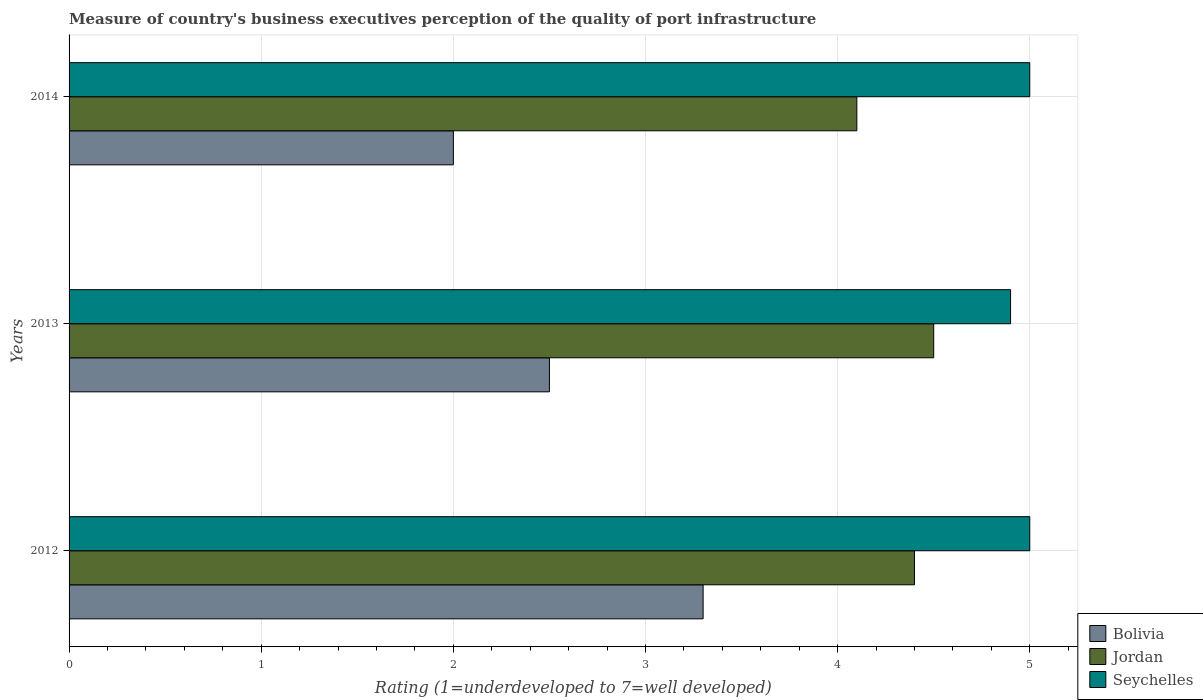Are the number of bars per tick equal to the number of legend labels?
Keep it short and to the point. Yes. Are the number of bars on each tick of the Y-axis equal?
Provide a succinct answer. Yes. How many bars are there on the 2nd tick from the top?
Keep it short and to the point. 3. Across all years, what is the maximum ratings of the quality of port infrastructure in Jordan?
Your response must be concise. 4.5. In which year was the ratings of the quality of port infrastructure in Seychelles minimum?
Give a very brief answer. 2013. What is the difference between the ratings of the quality of port infrastructure in Jordan in 2012 and that in 2013?
Offer a terse response. -0.1. What is the average ratings of the quality of port infrastructure in Seychelles per year?
Make the answer very short. 4.97. In the year 2014, what is the difference between the ratings of the quality of port infrastructure in Seychelles and ratings of the quality of port infrastructure in Jordan?
Give a very brief answer. 0.9. What is the ratio of the ratings of the quality of port infrastructure in Jordan in 2012 to that in 2014?
Offer a very short reply. 1.07. Is the ratings of the quality of port infrastructure in Seychelles in 2013 less than that in 2014?
Your answer should be very brief. Yes. What is the difference between the highest and the second highest ratings of the quality of port infrastructure in Jordan?
Keep it short and to the point. 0.1. What is the difference between the highest and the lowest ratings of the quality of port infrastructure in Bolivia?
Your answer should be compact. 1.3. In how many years, is the ratings of the quality of port infrastructure in Bolivia greater than the average ratings of the quality of port infrastructure in Bolivia taken over all years?
Your response must be concise. 1. What does the 1st bar from the top in 2012 represents?
Make the answer very short. Seychelles. What does the 3rd bar from the bottom in 2013 represents?
Give a very brief answer. Seychelles. Is it the case that in every year, the sum of the ratings of the quality of port infrastructure in Bolivia and ratings of the quality of port infrastructure in Seychelles is greater than the ratings of the quality of port infrastructure in Jordan?
Your answer should be very brief. Yes. How many years are there in the graph?
Offer a very short reply. 3. What is the difference between two consecutive major ticks on the X-axis?
Offer a terse response. 1. Are the values on the major ticks of X-axis written in scientific E-notation?
Offer a terse response. No. Does the graph contain any zero values?
Provide a succinct answer. No. Does the graph contain grids?
Your answer should be compact. Yes. How are the legend labels stacked?
Your answer should be compact. Vertical. What is the title of the graph?
Give a very brief answer. Measure of country's business executives perception of the quality of port infrastructure. Does "Haiti" appear as one of the legend labels in the graph?
Ensure brevity in your answer.  No. What is the label or title of the X-axis?
Your answer should be compact. Rating (1=underdeveloped to 7=well developed). What is the label or title of the Y-axis?
Provide a short and direct response. Years. What is the Rating (1=underdeveloped to 7=well developed) of Bolivia in 2012?
Your response must be concise. 3.3. What is the Rating (1=underdeveloped to 7=well developed) of Bolivia in 2013?
Ensure brevity in your answer.  2.5. What is the Rating (1=underdeveloped to 7=well developed) in Seychelles in 2013?
Give a very brief answer. 4.9. What is the Rating (1=underdeveloped to 7=well developed) in Bolivia in 2014?
Your response must be concise. 2. What is the total Rating (1=underdeveloped to 7=well developed) in Jordan in the graph?
Provide a succinct answer. 13. What is the difference between the Rating (1=underdeveloped to 7=well developed) of Jordan in 2012 and that in 2013?
Provide a short and direct response. -0.1. What is the difference between the Rating (1=underdeveloped to 7=well developed) of Jordan in 2012 and that in 2014?
Ensure brevity in your answer.  0.3. What is the difference between the Rating (1=underdeveloped to 7=well developed) in Bolivia in 2013 and that in 2014?
Your response must be concise. 0.5. What is the difference between the Rating (1=underdeveloped to 7=well developed) in Bolivia in 2012 and the Rating (1=underdeveloped to 7=well developed) in Seychelles in 2013?
Make the answer very short. -1.6. What is the difference between the Rating (1=underdeveloped to 7=well developed) in Bolivia in 2013 and the Rating (1=underdeveloped to 7=well developed) in Jordan in 2014?
Make the answer very short. -1.6. What is the difference between the Rating (1=underdeveloped to 7=well developed) of Bolivia in 2013 and the Rating (1=underdeveloped to 7=well developed) of Seychelles in 2014?
Provide a short and direct response. -2.5. What is the average Rating (1=underdeveloped to 7=well developed) of Bolivia per year?
Ensure brevity in your answer.  2.6. What is the average Rating (1=underdeveloped to 7=well developed) in Jordan per year?
Offer a terse response. 4.33. What is the average Rating (1=underdeveloped to 7=well developed) of Seychelles per year?
Give a very brief answer. 4.97. In the year 2012, what is the difference between the Rating (1=underdeveloped to 7=well developed) in Bolivia and Rating (1=underdeveloped to 7=well developed) in Jordan?
Give a very brief answer. -1.1. In the year 2013, what is the difference between the Rating (1=underdeveloped to 7=well developed) in Bolivia and Rating (1=underdeveloped to 7=well developed) in Jordan?
Your answer should be compact. -2. In the year 2013, what is the difference between the Rating (1=underdeveloped to 7=well developed) in Bolivia and Rating (1=underdeveloped to 7=well developed) in Seychelles?
Provide a short and direct response. -2.4. In the year 2014, what is the difference between the Rating (1=underdeveloped to 7=well developed) of Bolivia and Rating (1=underdeveloped to 7=well developed) of Seychelles?
Provide a succinct answer. -3. In the year 2014, what is the difference between the Rating (1=underdeveloped to 7=well developed) of Jordan and Rating (1=underdeveloped to 7=well developed) of Seychelles?
Provide a succinct answer. -0.9. What is the ratio of the Rating (1=underdeveloped to 7=well developed) of Bolivia in 2012 to that in 2013?
Give a very brief answer. 1.32. What is the ratio of the Rating (1=underdeveloped to 7=well developed) of Jordan in 2012 to that in 2013?
Keep it short and to the point. 0.98. What is the ratio of the Rating (1=underdeveloped to 7=well developed) in Seychelles in 2012 to that in 2013?
Make the answer very short. 1.02. What is the ratio of the Rating (1=underdeveloped to 7=well developed) in Bolivia in 2012 to that in 2014?
Offer a terse response. 1.65. What is the ratio of the Rating (1=underdeveloped to 7=well developed) in Jordan in 2012 to that in 2014?
Offer a terse response. 1.07. What is the ratio of the Rating (1=underdeveloped to 7=well developed) of Jordan in 2013 to that in 2014?
Your answer should be compact. 1.1. What is the difference between the highest and the second highest Rating (1=underdeveloped to 7=well developed) of Bolivia?
Ensure brevity in your answer.  0.8. What is the difference between the highest and the second highest Rating (1=underdeveloped to 7=well developed) in Jordan?
Your response must be concise. 0.1. What is the difference between the highest and the lowest Rating (1=underdeveloped to 7=well developed) in Seychelles?
Ensure brevity in your answer.  0.1. 